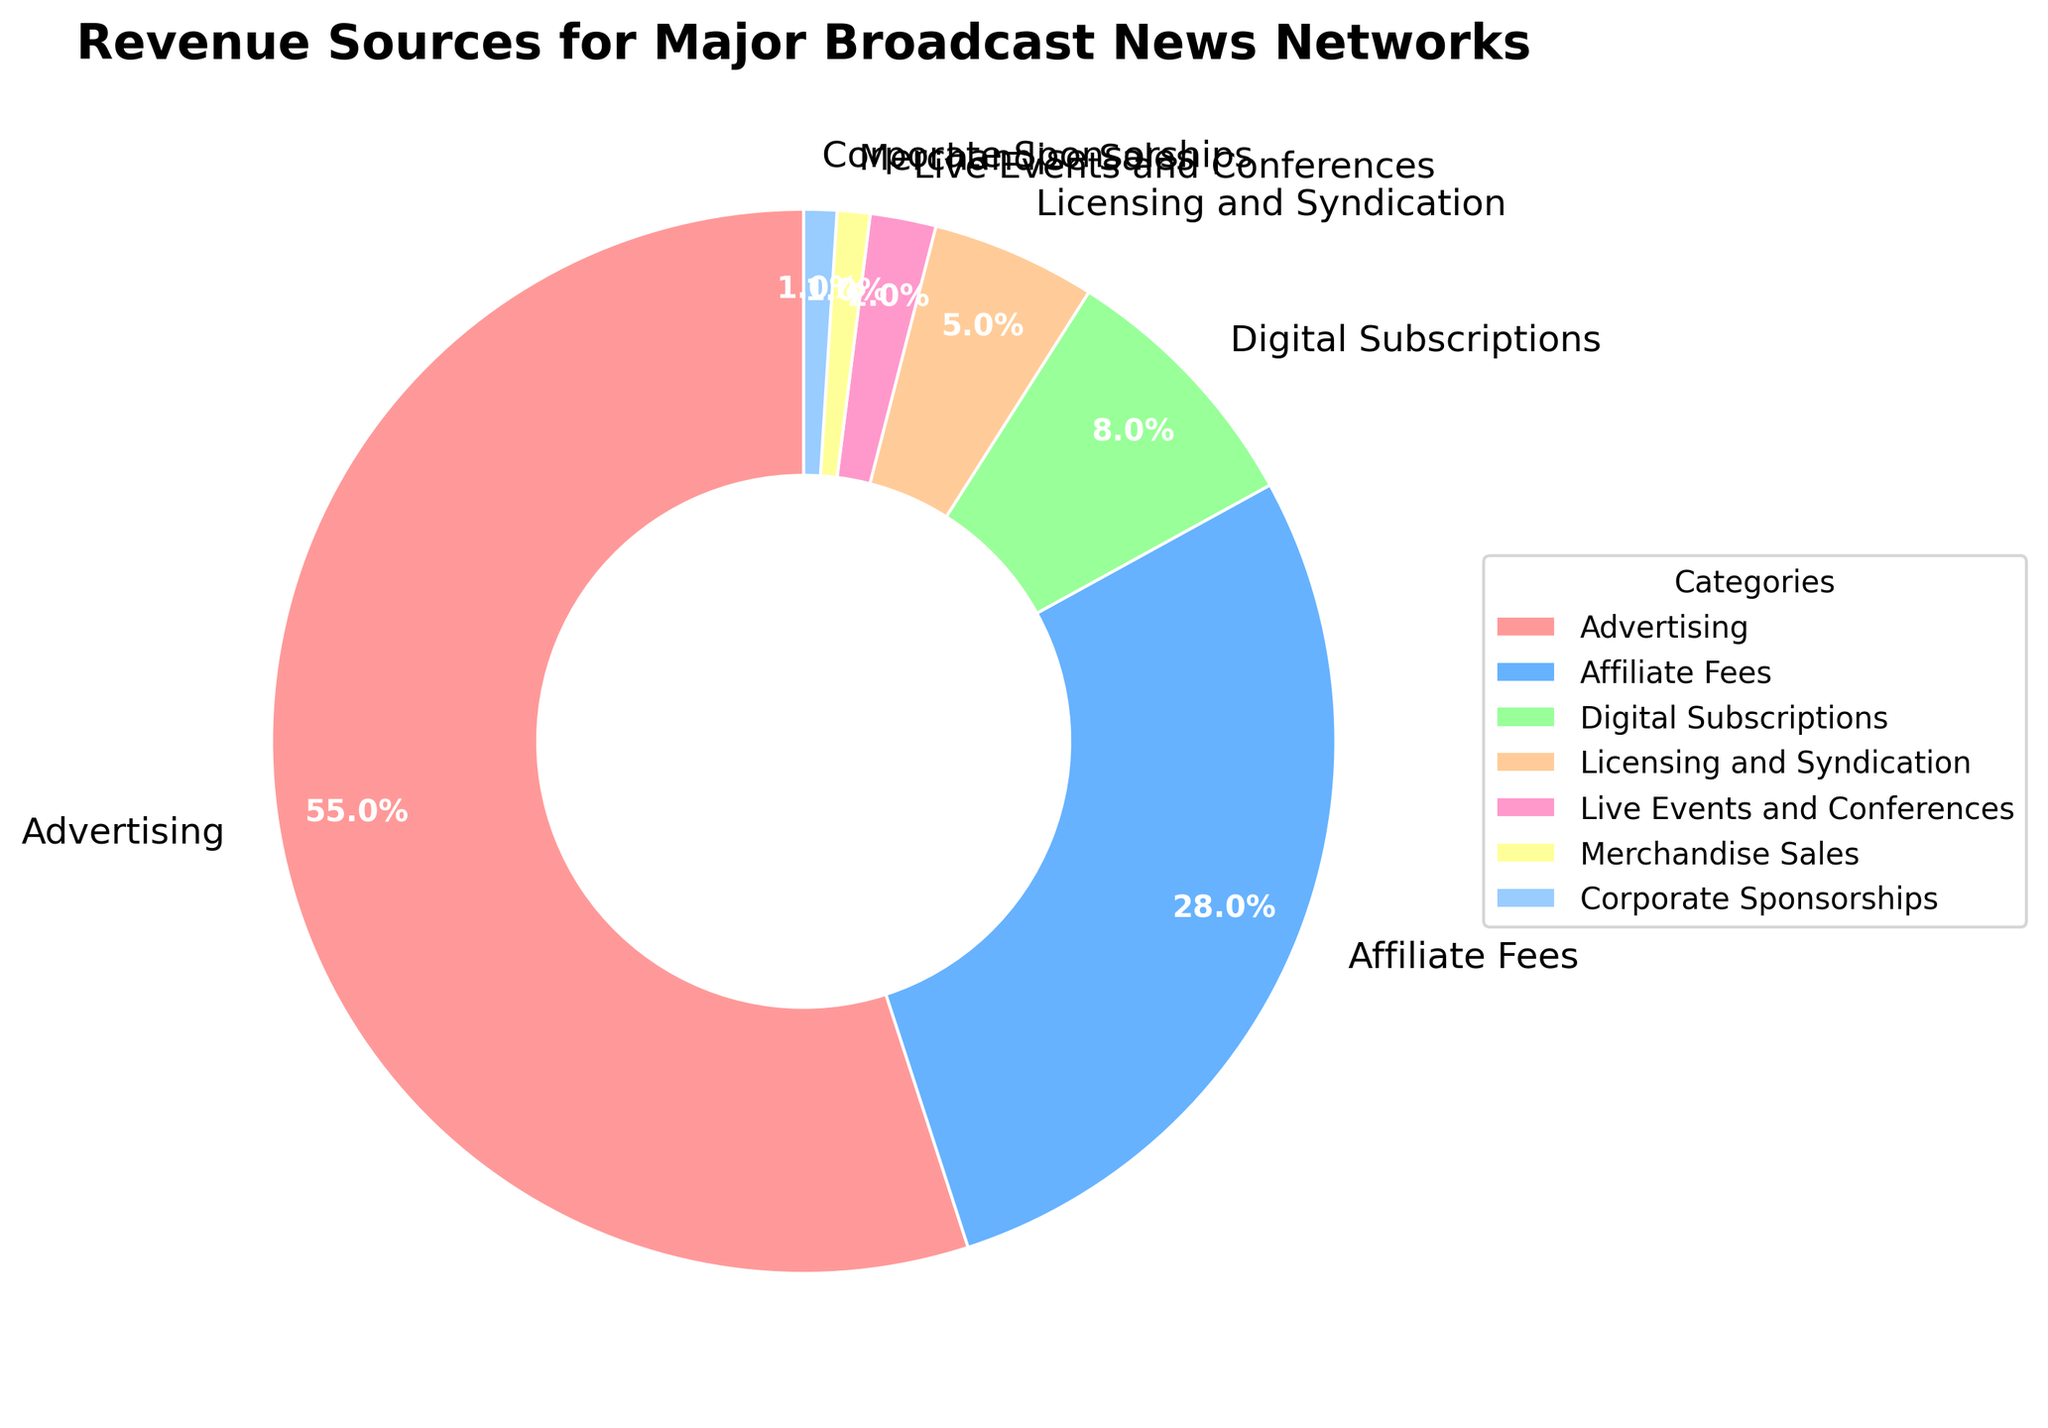What percentage of revenue comes from advertising? From the figure, the segment labeled "Advertising" indicates a percentage value of 55%. So, the percentage of revenue coming from advertising is the one shown in that segment.
Answer: 55% How much more revenue is generated from affiliate fees than from digital subscriptions? From the figure, affiliate fees contribute 28% while digital subscriptions contribute 8%. The difference is calculated as 28% - 8%.
Answer: 20% Which category generates the least revenue? The smallest segment on the pie chart represents merchandise sales and corporate sponsorships, each accounting for 1%.
Answer: Merchandise Sales and Corporate Sponsorships What is the combined revenue percentage of licensing and syndication and live events and conferences? Licensing and syndication contribute 5% and live events and conferences contribute 2%. The combined percentage is calculated as 5% + 2%.
Answer: 7% Is the revenue from digital subscriptions more than half of the revenue from affiliate fees? Digital subscriptions account for 8% and affiliate fees account for 28%. To find if digital subscriptions are more than half of affiliate fees: (28%/2) = 14%. Since 8% is less than 14%, digital subscriptions are not more than half of affiliate fees.
Answer: No Which two categories contribute the highest combined revenue percentage? The top two segments of the pie chart are Advertising (55%) and Affiliate Fees (28%). Their combined percentage is 55% + 28%.
Answer: Advertising and Affiliate Fees Which segment is represented by the color closest to blue? The segment with the color closest to blue is affiliate fees, represented by a blue-like color in the chart.
Answer: Affiliate Fees How does the revenue from live events and conferences compare to that from licensing and syndication? Live events and conferences have a revenue percentage of 2%, while licensing and syndication have 5%. Therefore, live events and conferences contribute less revenue than licensing and syndication.
Answer: Less What is the percentage difference between the highest and lowest revenue categories? The highest revenue category is advertising at 55%, and the lowest are merchandise sales and corporate sponsorships at 1%. The difference is calculated as 55% - 1%.
Answer: 54% What is the sum of the revenue percentages for categories that contribute less than 10% each? Categories contributing less than 10% are digital subscriptions (8%), licensing and syndication (5%), live events and conferences (2%), merchandise sales (1%), and corporate sponsorships (1%). Their sum is 8% + 5% + 2% + 1% + 1%.
Answer: 17% 